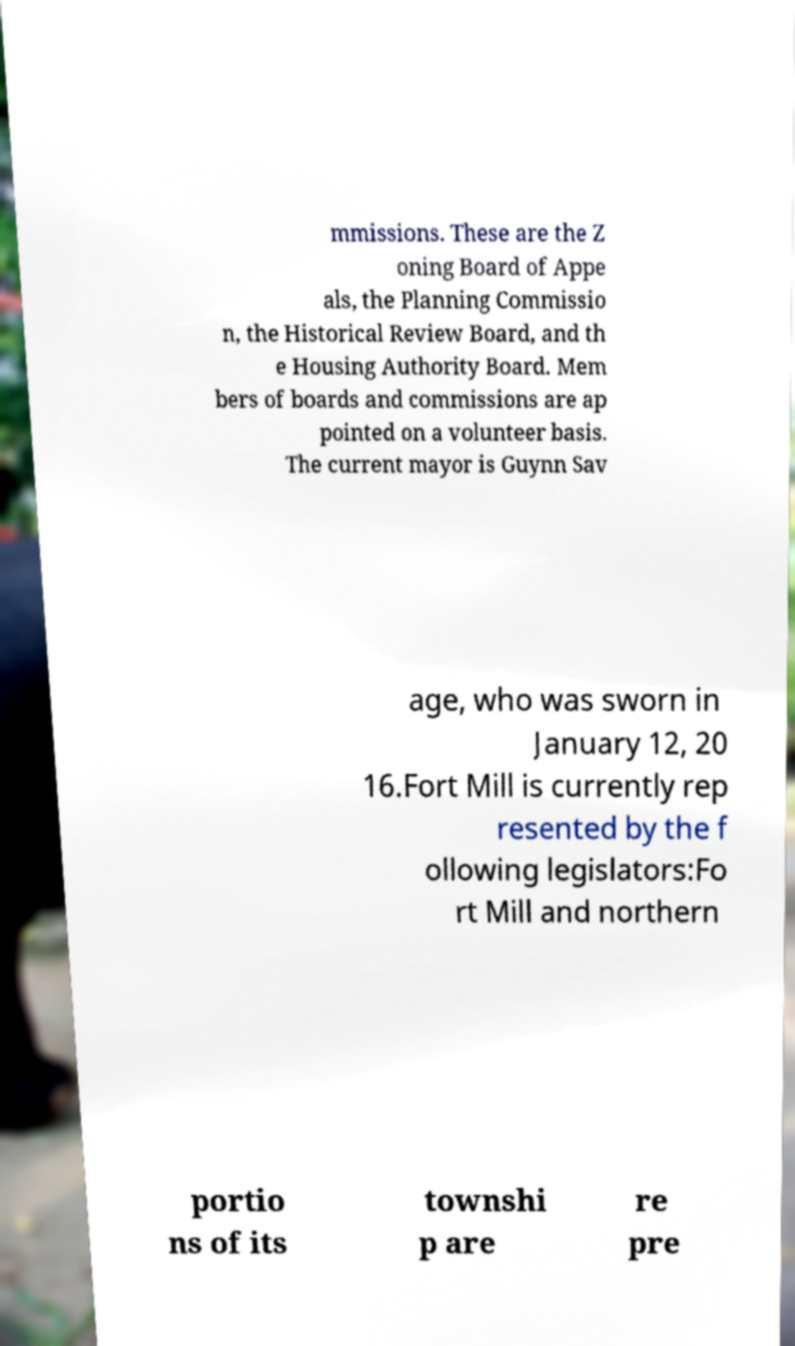Can you read and provide the text displayed in the image?This photo seems to have some interesting text. Can you extract and type it out for me? mmissions. These are the Z oning Board of Appe als, the Planning Commissio n, the Historical Review Board, and th e Housing Authority Board. Mem bers of boards and commissions are ap pointed on a volunteer basis. The current mayor is Guynn Sav age, who was sworn in January 12, 20 16.Fort Mill is currently rep resented by the f ollowing legislators:Fo rt Mill and northern portio ns of its townshi p are re pre 